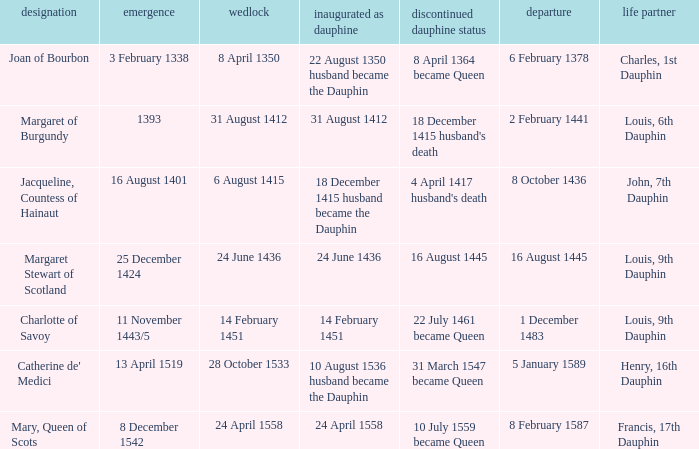Who is the husband when ceased to be dauphine is 22 july 1461 became queen? Louis, 9th Dauphin. 